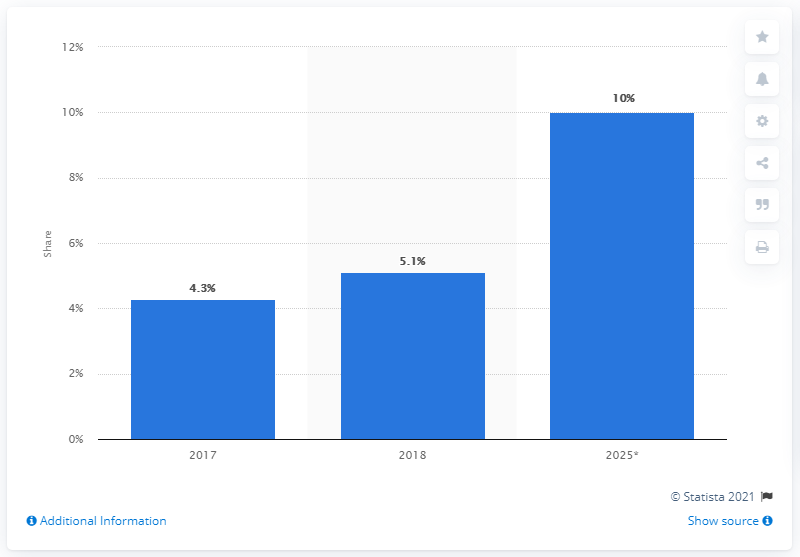Mention a couple of crucial points in this snapshot. In 2018, online sales of fast-moving consumer goods (FMCG) accounted for 5.1% of total global FMCG sales. 